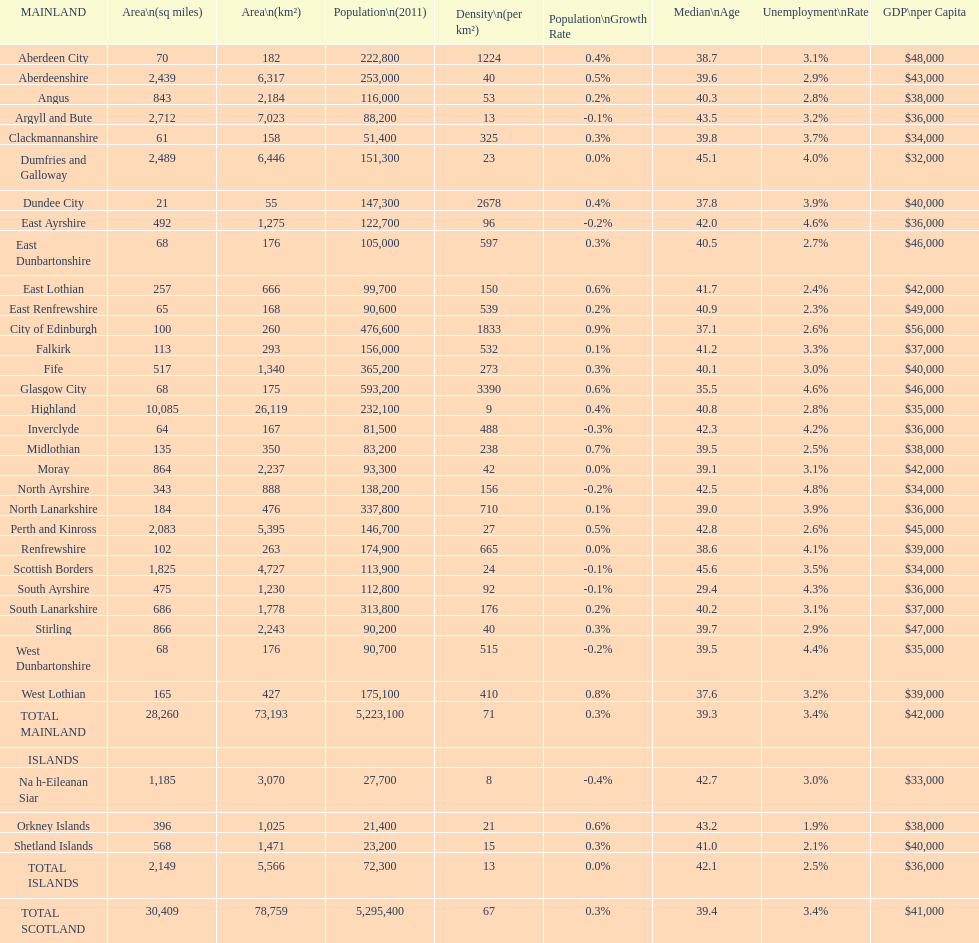Which is the only subdivision to have a greater area than argyll and bute? Highland. 